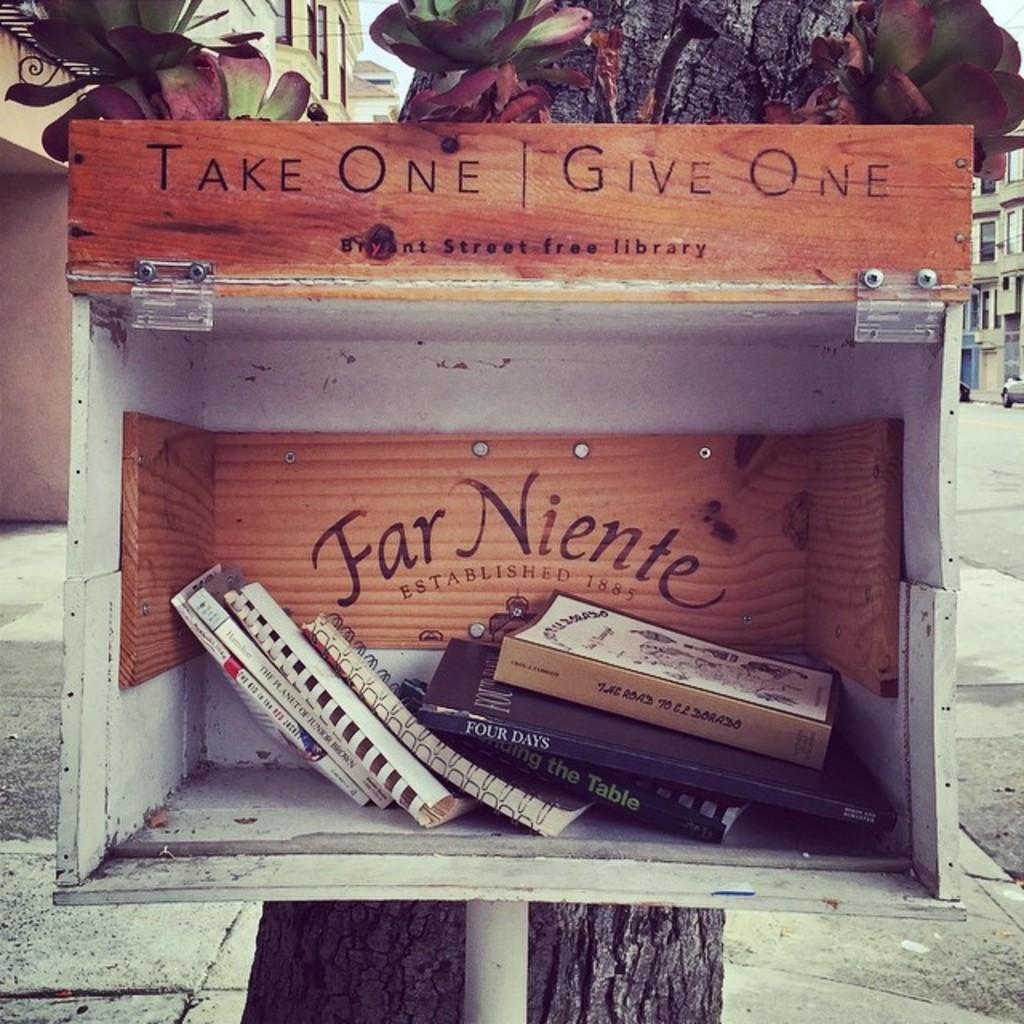<image>
Write a terse but informative summary of the picture. A Take One Give One book box has a few books inside. 